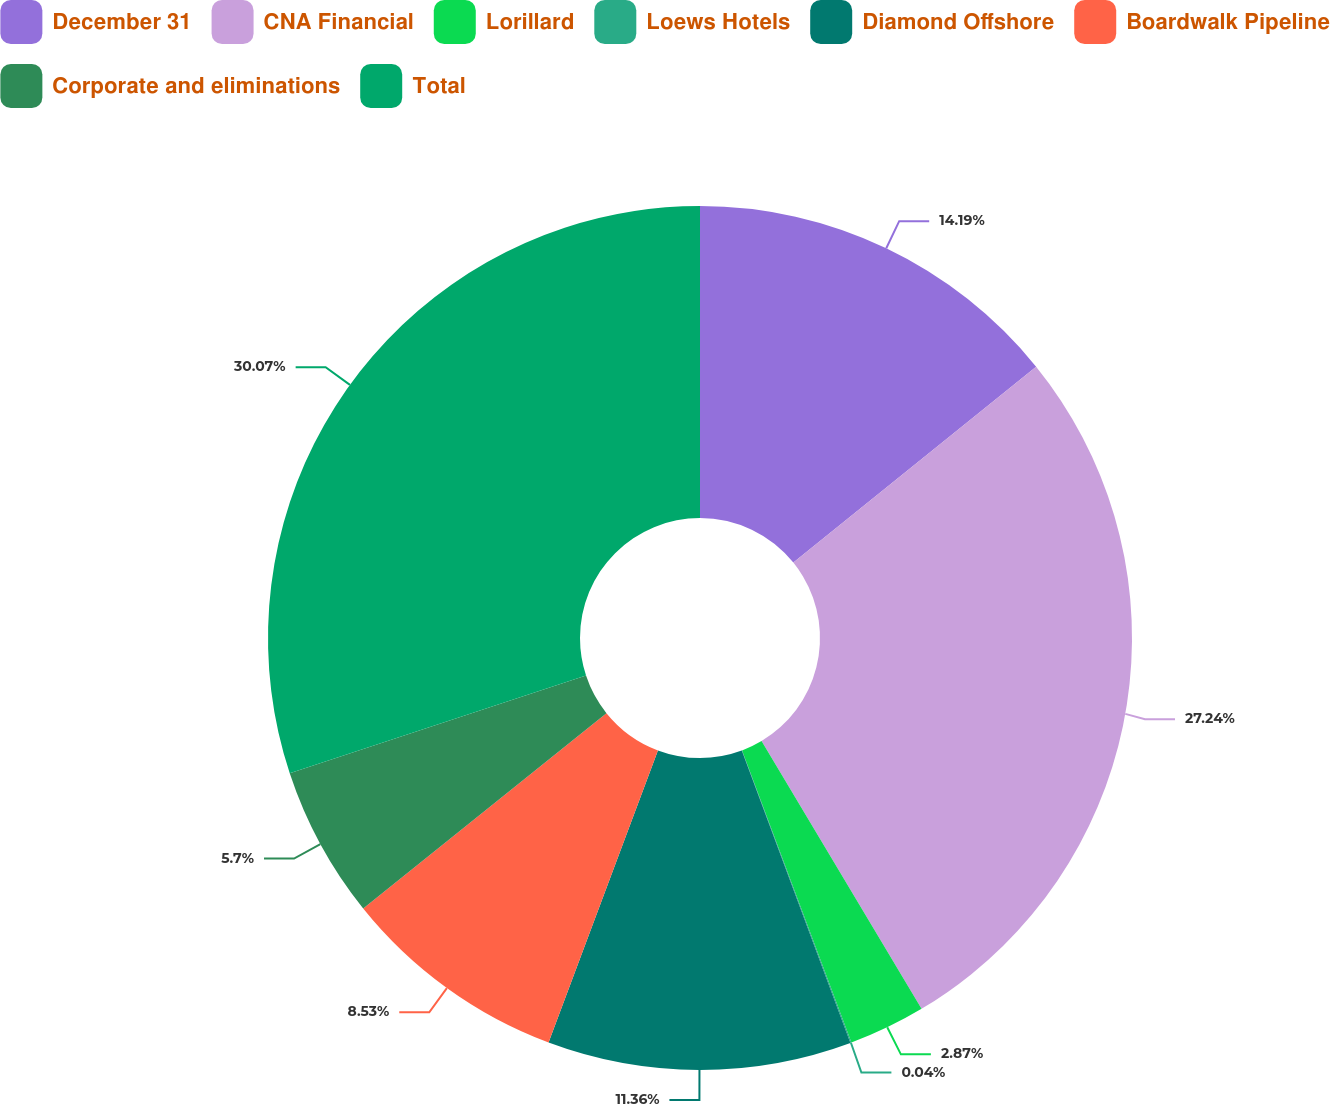<chart> <loc_0><loc_0><loc_500><loc_500><pie_chart><fcel>December 31<fcel>CNA Financial<fcel>Lorillard<fcel>Loews Hotels<fcel>Diamond Offshore<fcel>Boardwalk Pipeline<fcel>Corporate and eliminations<fcel>Total<nl><fcel>14.19%<fcel>27.24%<fcel>2.87%<fcel>0.04%<fcel>11.36%<fcel>8.53%<fcel>5.7%<fcel>30.07%<nl></chart> 